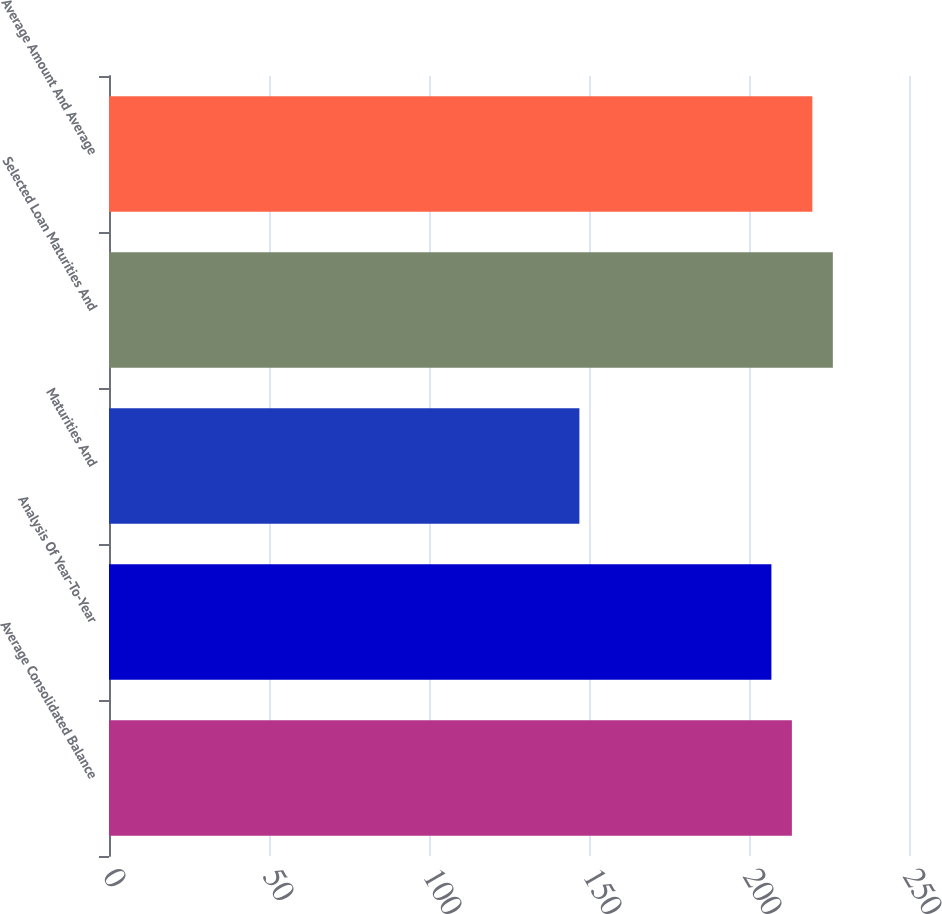Convert chart to OTSL. <chart><loc_0><loc_0><loc_500><loc_500><bar_chart><fcel>Average Consolidated Balance<fcel>Analysis Of Year-To-Year<fcel>Maturities And<fcel>Selected Loan Maturities And<fcel>Average Amount And Average<nl><fcel>213.4<fcel>207<fcel>147<fcel>226.2<fcel>219.8<nl></chart> 